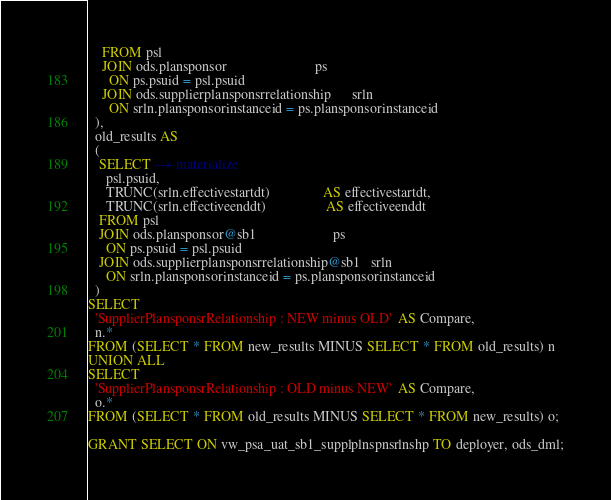Convert code to text. <code><loc_0><loc_0><loc_500><loc_500><_SQL_>    FROM psl                                     
    JOIN ods.plansponsor                         ps
      ON ps.psuid = psl.psuid                            
    JOIN ods.supplierplansponsrrelationship      srln 
      ON srln.plansponsorinstanceid = ps.plansponsorinstanceid
  ),      
  old_results AS
  (
   SELECT --+ materialize
     psl.psuid,
     TRUNC(srln.effectivestartdt)               AS effectivestartdt,
     TRUNC(srln.effectiveenddt)                 AS effectiveenddt
   FROM psl                             
   JOIN ods.plansponsor@sb1                      ps 
     ON ps.psuid = psl.psuid                            
   JOIN ods.supplierplansponsrrelationship@sb1   srln
     ON srln.plansponsorinstanceid = ps.plansponsorinstanceid
  )
SELECT
  'SupplierPlansponsrRelationship : NEW minus OLD'  AS Compare,
  n.* 
FROM (SELECT * FROM new_results MINUS SELECT * FROM old_results) n
UNION ALL
SELECT
  'SupplierPlansponsrRelationship : OLD minus NEW'  AS Compare,
  o.* 
FROM (SELECT * FROM old_results MINUS SELECT * FROM new_results) o;

GRANT SELECT ON vw_psa_uat_sb1_supplplnspnsrlnshp TO deployer, ods_dml;</code> 